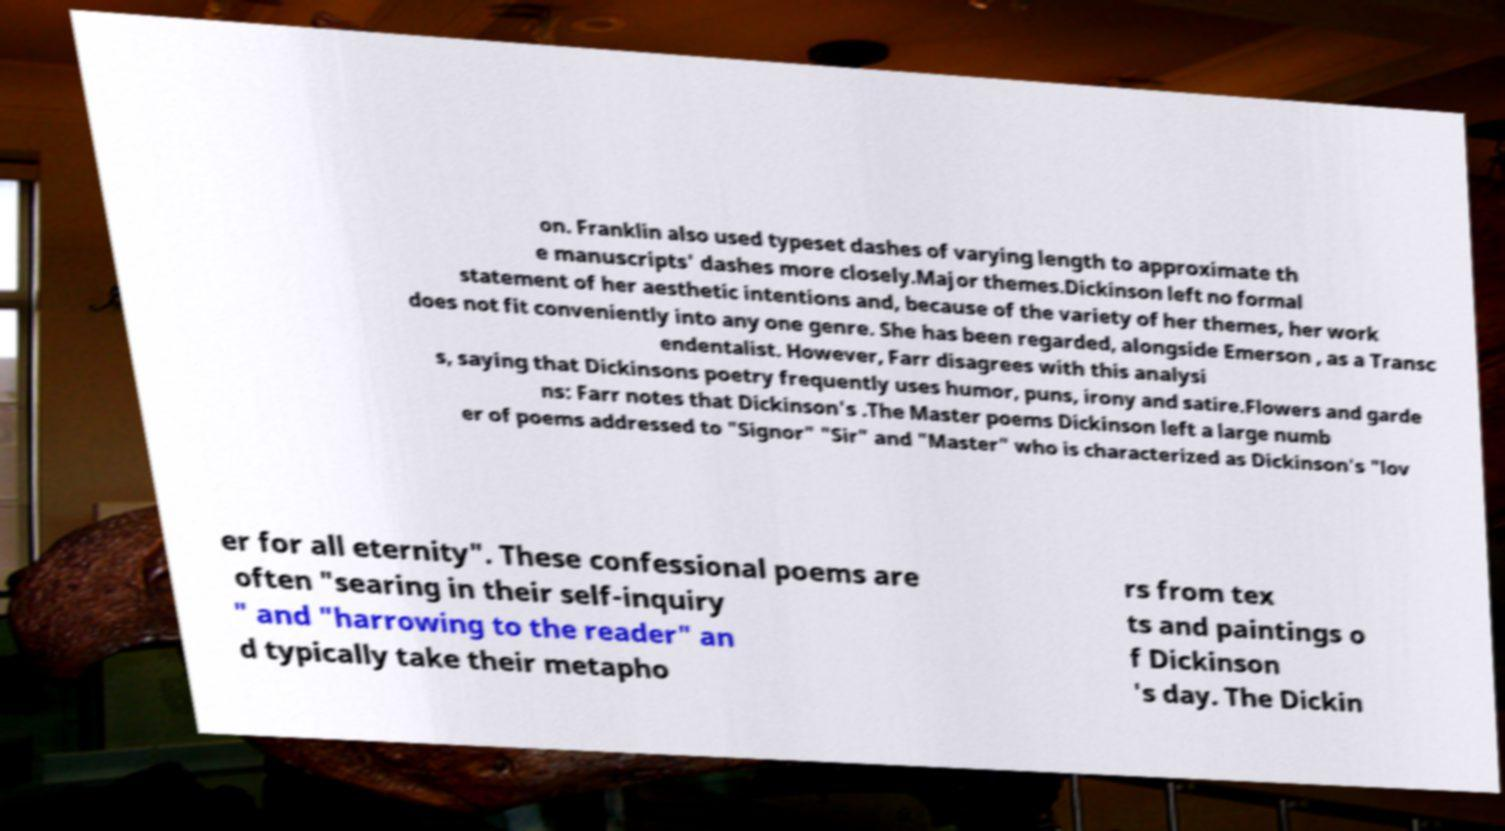Please identify and transcribe the text found in this image. on. Franklin also used typeset dashes of varying length to approximate th e manuscripts' dashes more closely.Major themes.Dickinson left no formal statement of her aesthetic intentions and, because of the variety of her themes, her work does not fit conveniently into any one genre. She has been regarded, alongside Emerson , as a Transc endentalist. However, Farr disagrees with this analysi s, saying that Dickinsons poetry frequently uses humor, puns, irony and satire.Flowers and garde ns: Farr notes that Dickinson's .The Master poems Dickinson left a large numb er of poems addressed to "Signor" "Sir" and "Master" who is characterized as Dickinson's "lov er for all eternity". These confessional poems are often "searing in their self-inquiry " and "harrowing to the reader" an d typically take their metapho rs from tex ts and paintings o f Dickinson 's day. The Dickin 